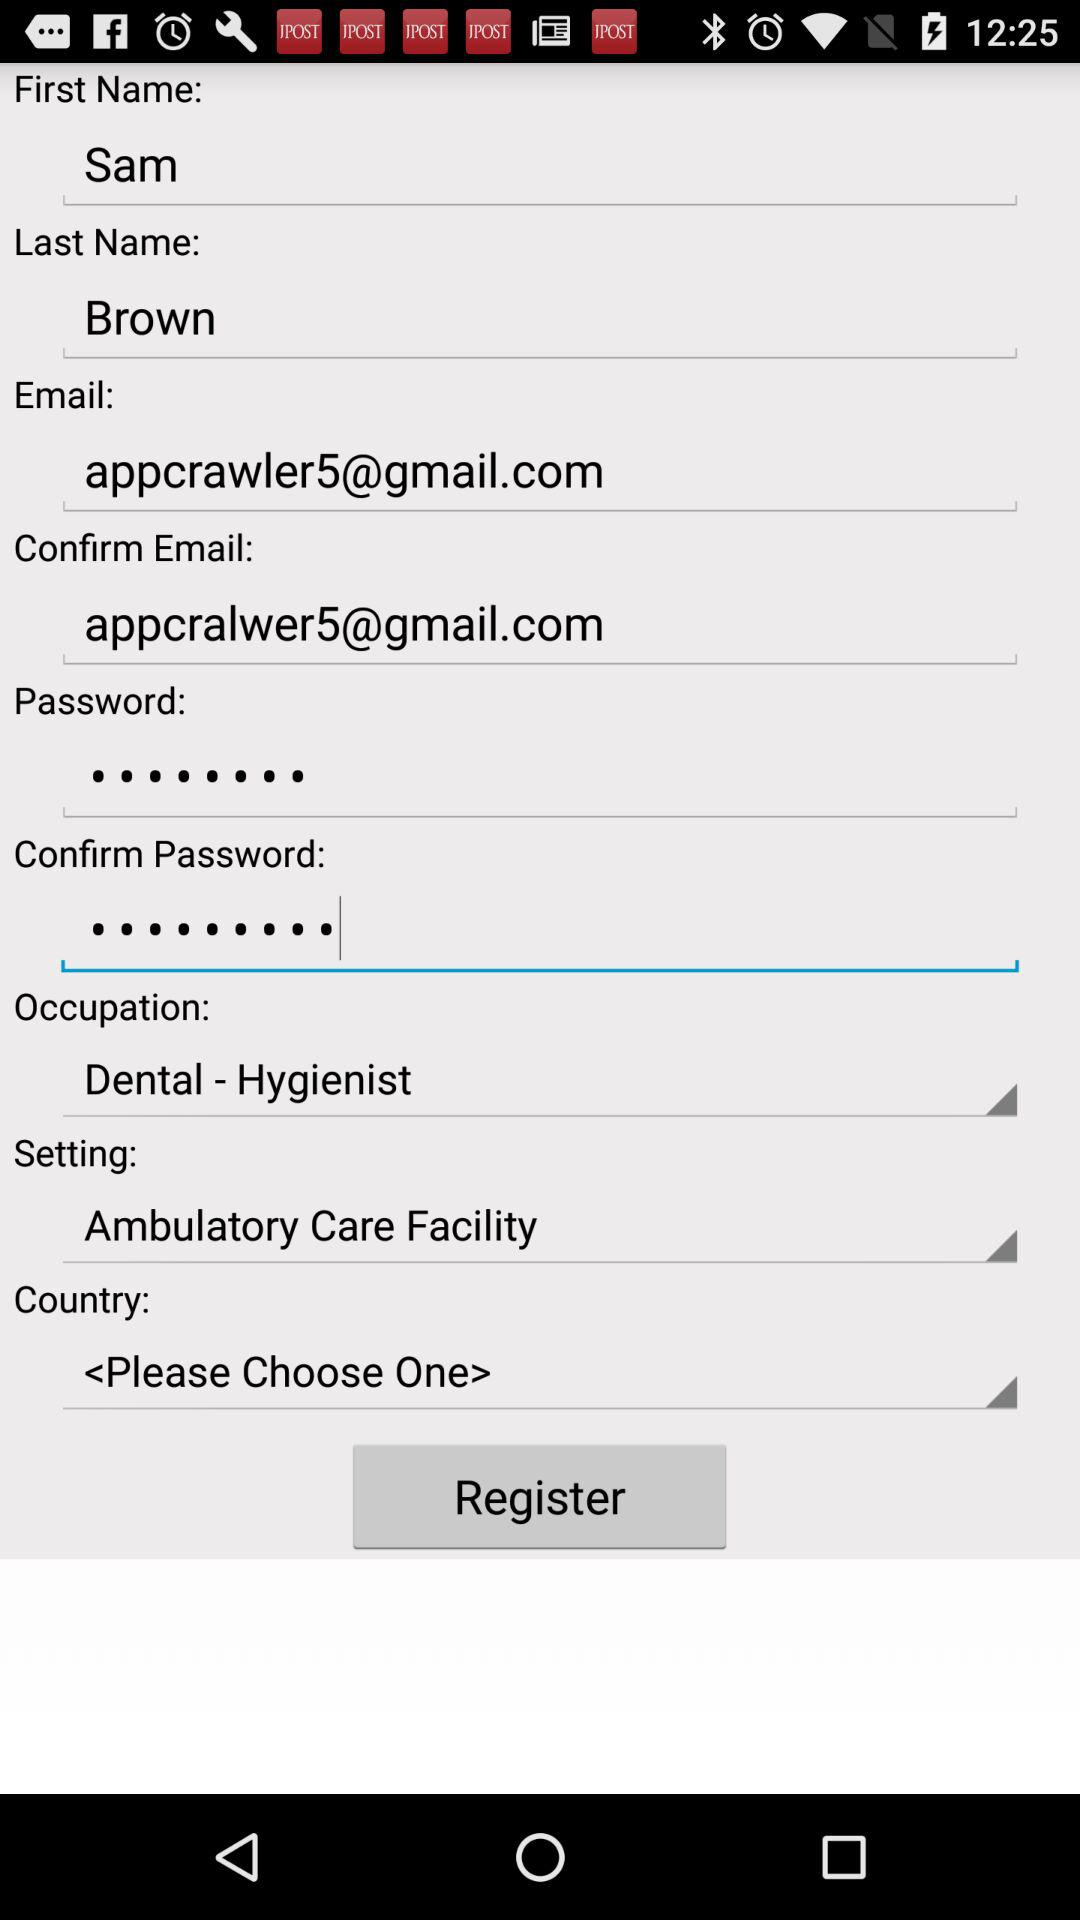What is the first name? The first name is Sam. 